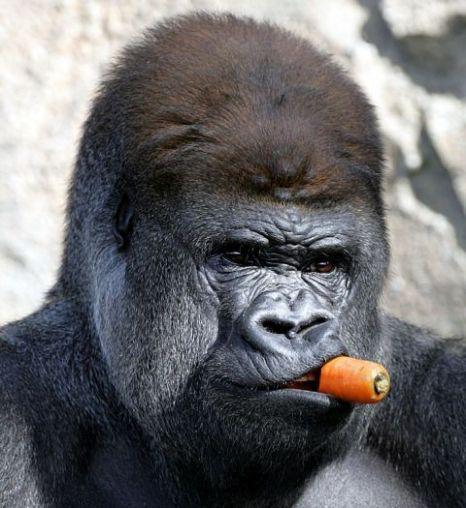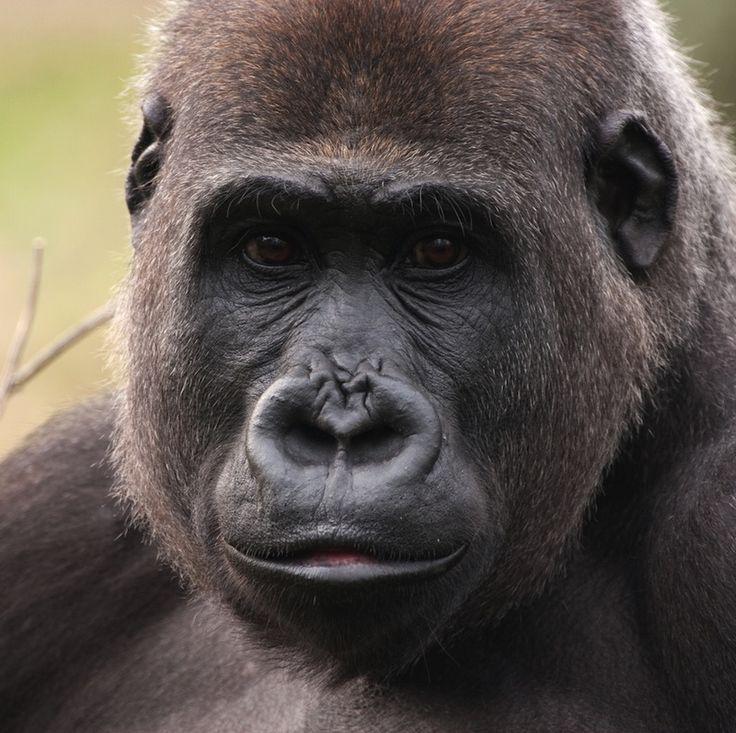The first image is the image on the left, the second image is the image on the right. Examine the images to the left and right. Is the description "In at least one image there is a gorilla with his mouth wide open." accurate? Answer yes or no. No. The first image is the image on the left, the second image is the image on the right. Analyze the images presented: Is the assertion "An ape has its mouth open." valid? Answer yes or no. No. 